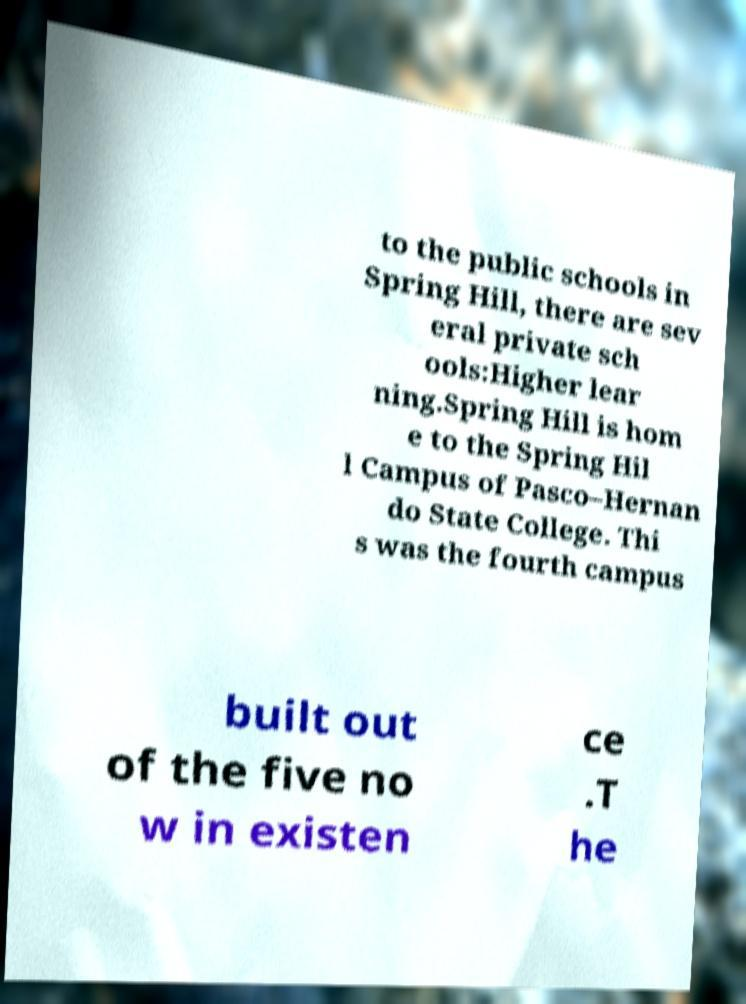Please identify and transcribe the text found in this image. to the public schools in Spring Hill, there are sev eral private sch ools:Higher lear ning.Spring Hill is hom e to the Spring Hil l Campus of Pasco–Hernan do State College. Thi s was the fourth campus built out of the five no w in existen ce .T he 